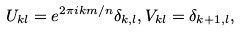Convert formula to latex. <formula><loc_0><loc_0><loc_500><loc_500>U _ { k l } = e ^ { 2 \pi i k m / n } \delta _ { k , l } , V _ { k l } = \delta _ { k + 1 , l } ,</formula> 